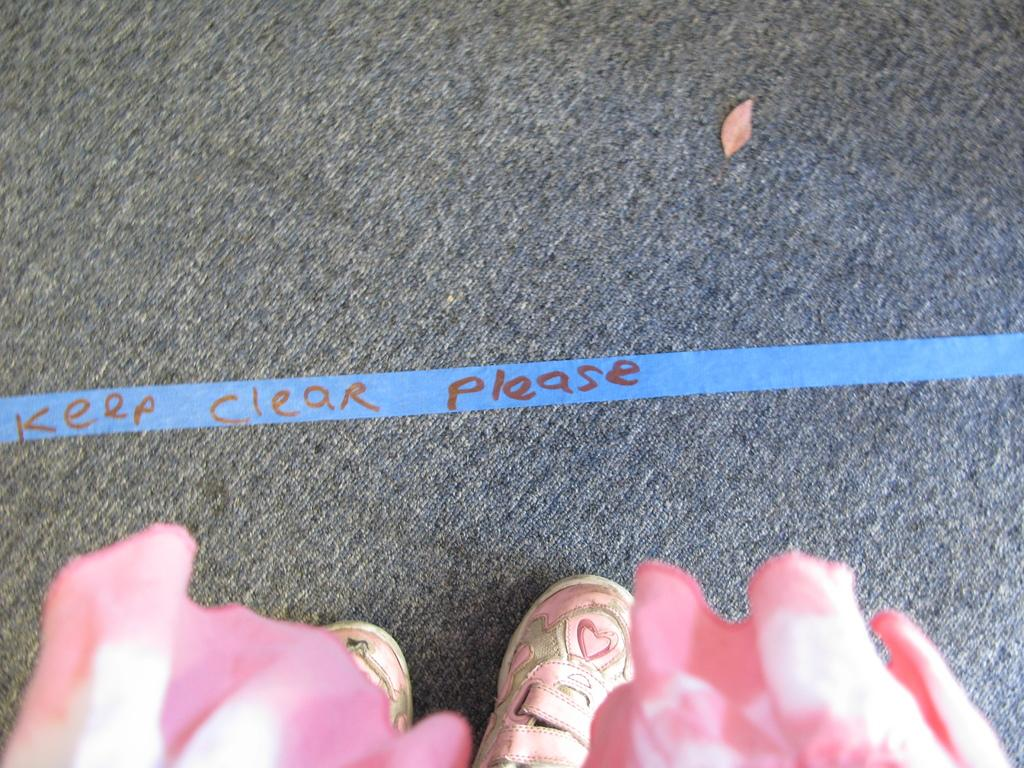What objects are located at the bottom of the image? There are two shoes at the bottom of the image. What color is the cloth visible in the image? The cloth in the image is pink. What is in the middle of the image? There is a mat in the middle of the image. What is written on the ribbon in the image? There is a text on a ribbon in the image. What type of boundary is depicted in the image? There is no boundary depicted in the image. What can be seen in the image that relates to science? The image does not contain any elements related to science. 